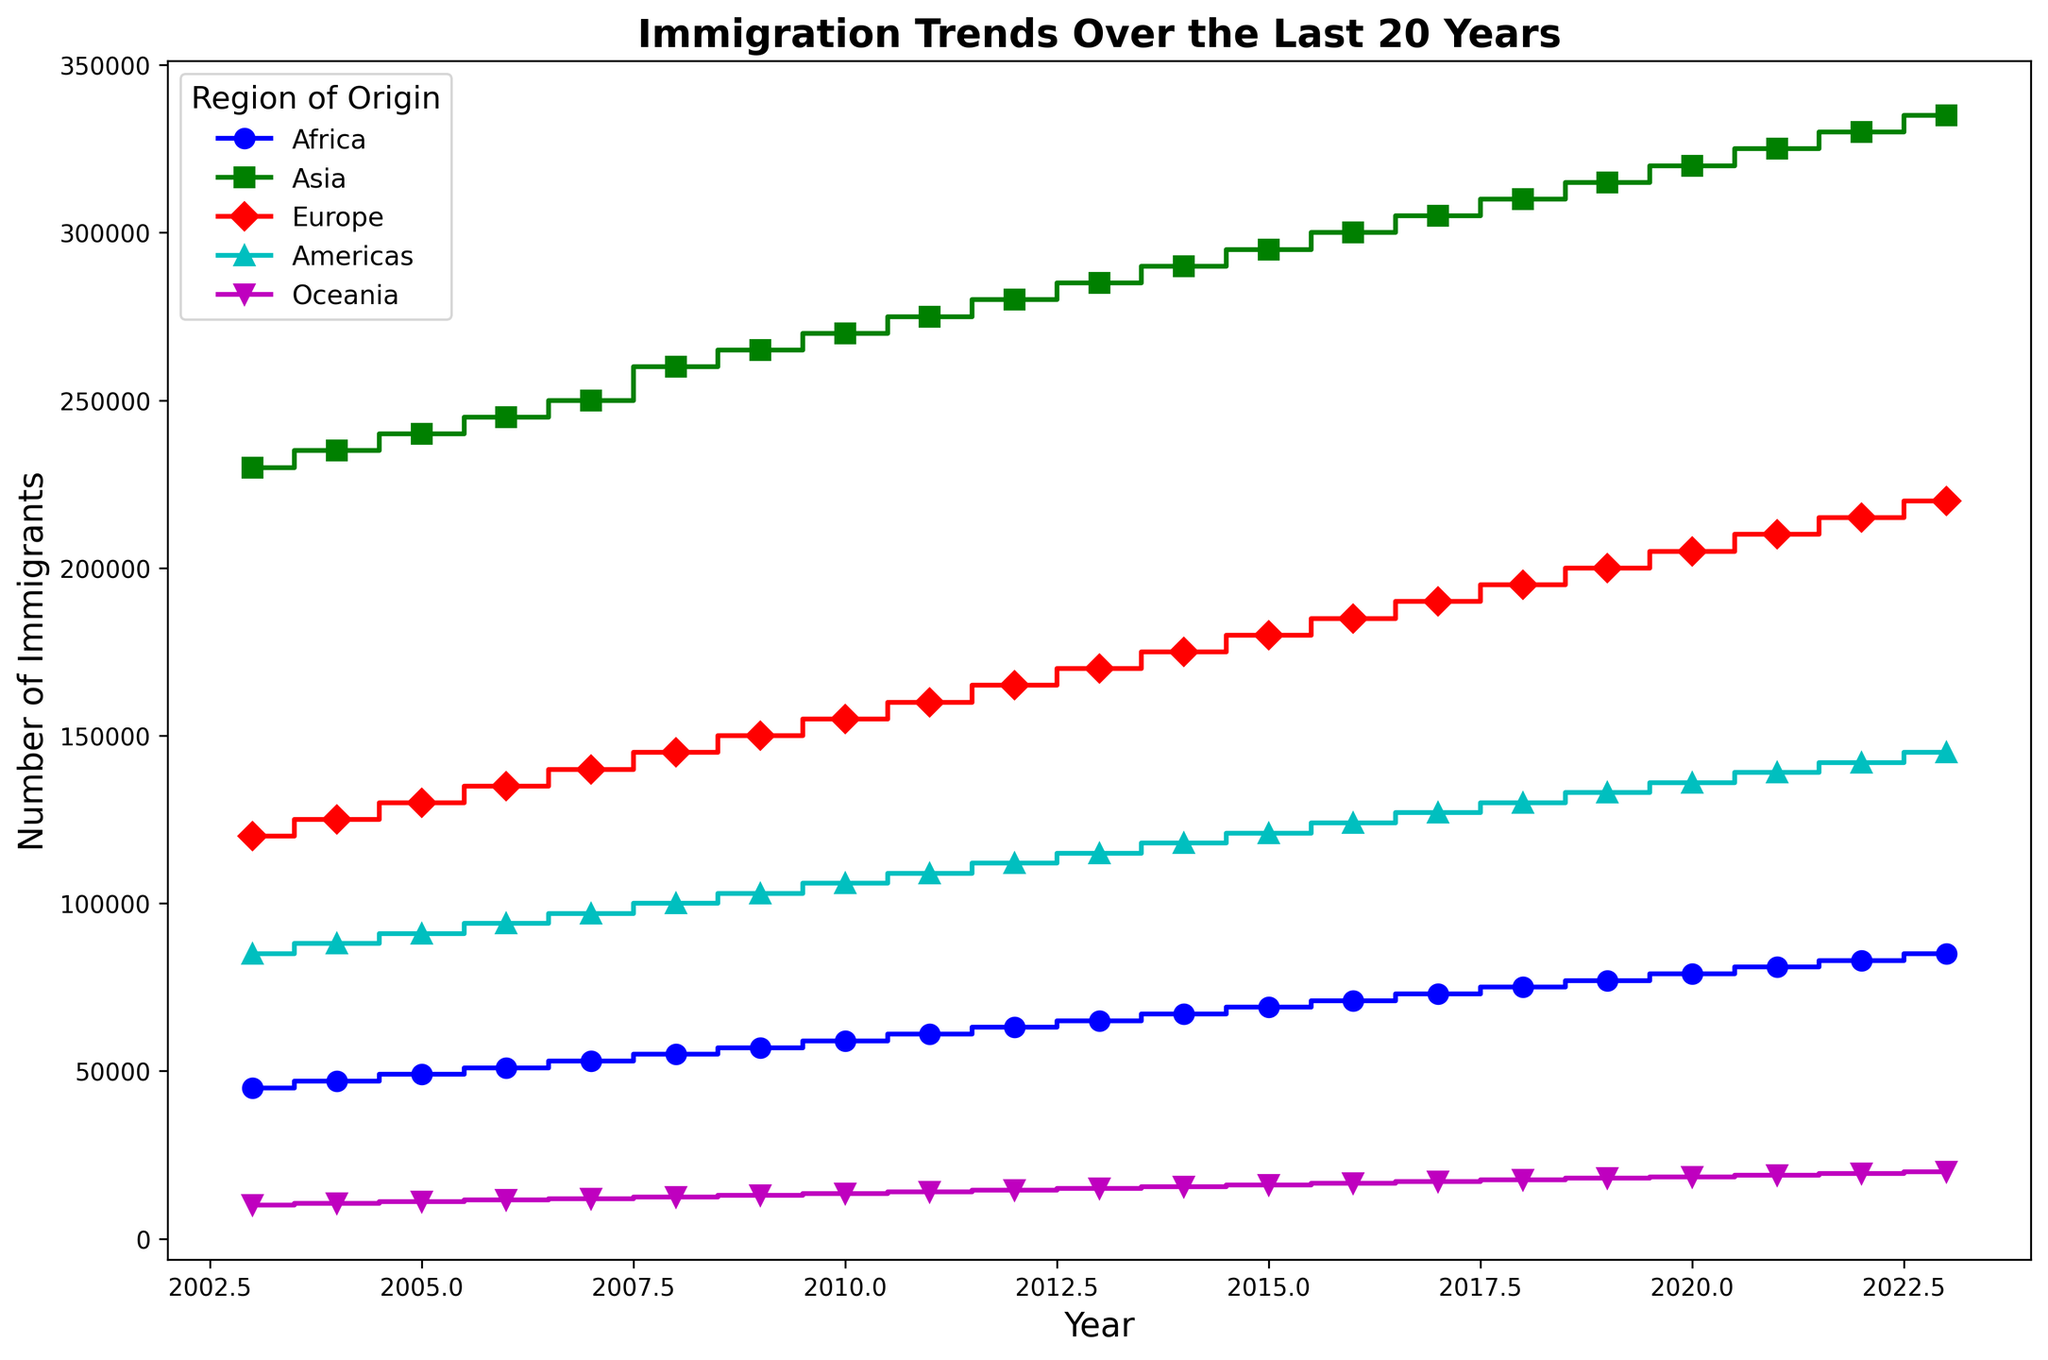Which region has the highest number of immigrants in 2023? Observing the plot, the region with the highest point in the year 2023 is Asia, as it is positioned at the top of the y-axis scale.
Answer: Asia Which region had the lowest increase in immigration numbers from 2003 to 2023? If you compare the length (or height) of the stairs plots across the years for each region, Oceania shows the smallest increment from 10,000 to 20,000, compared to other regions.
Answer: Oceania Between 2010 and 2020, which region had the largest increase in the number of immigrants? Analyzing the differences in heights of the steps in this period, Asia has the largest increase, going from 270,000 in 2010 to 320,000 in 2020.
Answer: Asia What is the total number of immigrants in 2020 from Asia and Africa combined? From the plot, the number of immigrants from Asia in 2020 is 320,000 and from Africa is 79,000. So, the sum is 320,000 + 79,000.
Answer: 399,000 Do the Americas or Europe show a steadier growth trend over the years? By visually comparing the smoothness and gradualness of the steps, the Americas have a more consistent, steady growth compared to the somewhat steeper steps seen for Europe.
Answer: Americas In which year was the number of immigrants from Europe equal to the immigrants from Americas? On observing the plot, the curves of Europe and Americas intersect at 2013, indicating they had equal numbers that year.
Answer: 2013 Which region had the most significant jump in immigrant numbers between two consecutive years? The largest vertical step observed is for Asia between 2007 (250,000) and 2008 (260,000) indicating a jump of 10,000, which is the largest.
Answer: Asia What was the average number of immigrants from Oceania between 2005 and 2010? The immigration numbers from Oceania are 11,000 (2005), 11,500 (2006), 12,000 (2007), 12,500 (2008), 13,000 (2009), and 13,500 (2010). Summing these, we get 73,500 and dividing by 6 years gives the average: 73,500 / 6.
Answer: 12,250 Which two regions show similar patterns in their immigration numbers over the years? Visually examining the shape and trajectory of the steps, Europe and Americas exhibit a somewhat similar growth pattern, increasing steadily.
Answer: Europe and Americas 